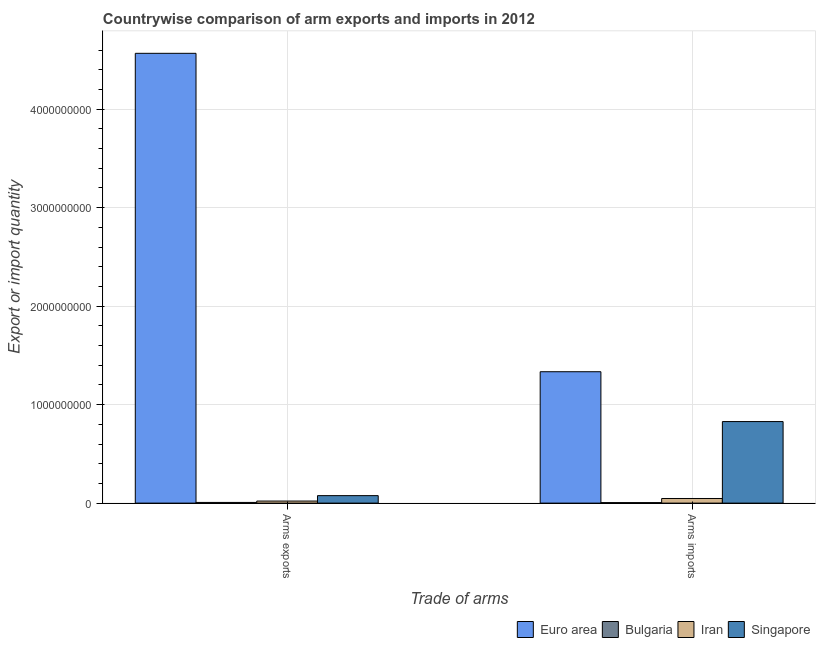How many bars are there on the 2nd tick from the left?
Keep it short and to the point. 4. How many bars are there on the 1st tick from the right?
Keep it short and to the point. 4. What is the label of the 1st group of bars from the left?
Provide a succinct answer. Arms exports. What is the arms exports in Iran?
Keep it short and to the point. 2.10e+07. Across all countries, what is the maximum arms imports?
Your answer should be compact. 1.33e+09. Across all countries, what is the minimum arms imports?
Keep it short and to the point. 5.00e+06. In which country was the arms imports minimum?
Give a very brief answer. Bulgaria. What is the total arms imports in the graph?
Your answer should be compact. 2.21e+09. What is the difference between the arms imports in Singapore and that in Euro area?
Your answer should be very brief. -5.06e+08. What is the difference between the arms exports in Singapore and the arms imports in Bulgaria?
Offer a very short reply. 7.10e+07. What is the average arms imports per country?
Your answer should be very brief. 5.54e+08. What is the difference between the arms imports and arms exports in Bulgaria?
Your answer should be very brief. -2.00e+06. What is the ratio of the arms imports in Bulgaria to that in Singapore?
Provide a short and direct response. 0.01. In how many countries, is the arms exports greater than the average arms exports taken over all countries?
Offer a terse response. 1. What does the 4th bar from the left in Arms exports represents?
Offer a very short reply. Singapore. What does the 1st bar from the right in Arms imports represents?
Offer a terse response. Singapore. How many bars are there?
Ensure brevity in your answer.  8. Are all the bars in the graph horizontal?
Offer a terse response. No. How many countries are there in the graph?
Offer a very short reply. 4. Are the values on the major ticks of Y-axis written in scientific E-notation?
Give a very brief answer. No. Where does the legend appear in the graph?
Provide a short and direct response. Bottom right. How many legend labels are there?
Offer a terse response. 4. How are the legend labels stacked?
Keep it short and to the point. Horizontal. What is the title of the graph?
Your answer should be compact. Countrywise comparison of arm exports and imports in 2012. Does "Rwanda" appear as one of the legend labels in the graph?
Offer a terse response. No. What is the label or title of the X-axis?
Your answer should be very brief. Trade of arms. What is the label or title of the Y-axis?
Ensure brevity in your answer.  Export or import quantity. What is the Export or import quantity of Euro area in Arms exports?
Ensure brevity in your answer.  4.57e+09. What is the Export or import quantity in Bulgaria in Arms exports?
Your answer should be very brief. 7.00e+06. What is the Export or import quantity of Iran in Arms exports?
Provide a succinct answer. 2.10e+07. What is the Export or import quantity of Singapore in Arms exports?
Keep it short and to the point. 7.60e+07. What is the Export or import quantity in Euro area in Arms imports?
Your response must be concise. 1.33e+09. What is the Export or import quantity in Iran in Arms imports?
Your answer should be compact. 4.70e+07. What is the Export or import quantity of Singapore in Arms imports?
Offer a very short reply. 8.28e+08. Across all Trade of arms, what is the maximum Export or import quantity in Euro area?
Offer a terse response. 4.57e+09. Across all Trade of arms, what is the maximum Export or import quantity in Bulgaria?
Your answer should be compact. 7.00e+06. Across all Trade of arms, what is the maximum Export or import quantity in Iran?
Your answer should be very brief. 4.70e+07. Across all Trade of arms, what is the maximum Export or import quantity of Singapore?
Keep it short and to the point. 8.28e+08. Across all Trade of arms, what is the minimum Export or import quantity in Euro area?
Make the answer very short. 1.33e+09. Across all Trade of arms, what is the minimum Export or import quantity in Bulgaria?
Keep it short and to the point. 5.00e+06. Across all Trade of arms, what is the minimum Export or import quantity of Iran?
Make the answer very short. 2.10e+07. Across all Trade of arms, what is the minimum Export or import quantity of Singapore?
Give a very brief answer. 7.60e+07. What is the total Export or import quantity in Euro area in the graph?
Your answer should be very brief. 5.90e+09. What is the total Export or import quantity of Iran in the graph?
Your answer should be compact. 6.80e+07. What is the total Export or import quantity of Singapore in the graph?
Offer a very short reply. 9.04e+08. What is the difference between the Export or import quantity in Euro area in Arms exports and that in Arms imports?
Your answer should be very brief. 3.23e+09. What is the difference between the Export or import quantity in Iran in Arms exports and that in Arms imports?
Offer a terse response. -2.60e+07. What is the difference between the Export or import quantity of Singapore in Arms exports and that in Arms imports?
Offer a very short reply. -7.52e+08. What is the difference between the Export or import quantity of Euro area in Arms exports and the Export or import quantity of Bulgaria in Arms imports?
Your response must be concise. 4.56e+09. What is the difference between the Export or import quantity in Euro area in Arms exports and the Export or import quantity in Iran in Arms imports?
Give a very brief answer. 4.52e+09. What is the difference between the Export or import quantity of Euro area in Arms exports and the Export or import quantity of Singapore in Arms imports?
Make the answer very short. 3.74e+09. What is the difference between the Export or import quantity in Bulgaria in Arms exports and the Export or import quantity in Iran in Arms imports?
Offer a very short reply. -4.00e+07. What is the difference between the Export or import quantity in Bulgaria in Arms exports and the Export or import quantity in Singapore in Arms imports?
Offer a terse response. -8.21e+08. What is the difference between the Export or import quantity of Iran in Arms exports and the Export or import quantity of Singapore in Arms imports?
Offer a terse response. -8.07e+08. What is the average Export or import quantity in Euro area per Trade of arms?
Make the answer very short. 2.95e+09. What is the average Export or import quantity of Iran per Trade of arms?
Make the answer very short. 3.40e+07. What is the average Export or import quantity of Singapore per Trade of arms?
Offer a terse response. 4.52e+08. What is the difference between the Export or import quantity in Euro area and Export or import quantity in Bulgaria in Arms exports?
Your answer should be compact. 4.56e+09. What is the difference between the Export or import quantity in Euro area and Export or import quantity in Iran in Arms exports?
Offer a terse response. 4.55e+09. What is the difference between the Export or import quantity in Euro area and Export or import quantity in Singapore in Arms exports?
Ensure brevity in your answer.  4.49e+09. What is the difference between the Export or import quantity in Bulgaria and Export or import quantity in Iran in Arms exports?
Your answer should be very brief. -1.40e+07. What is the difference between the Export or import quantity of Bulgaria and Export or import quantity of Singapore in Arms exports?
Ensure brevity in your answer.  -6.90e+07. What is the difference between the Export or import quantity of Iran and Export or import quantity of Singapore in Arms exports?
Your answer should be very brief. -5.50e+07. What is the difference between the Export or import quantity of Euro area and Export or import quantity of Bulgaria in Arms imports?
Provide a short and direct response. 1.33e+09. What is the difference between the Export or import quantity of Euro area and Export or import quantity of Iran in Arms imports?
Your response must be concise. 1.29e+09. What is the difference between the Export or import quantity in Euro area and Export or import quantity in Singapore in Arms imports?
Ensure brevity in your answer.  5.06e+08. What is the difference between the Export or import quantity in Bulgaria and Export or import quantity in Iran in Arms imports?
Ensure brevity in your answer.  -4.20e+07. What is the difference between the Export or import quantity in Bulgaria and Export or import quantity in Singapore in Arms imports?
Provide a short and direct response. -8.23e+08. What is the difference between the Export or import quantity of Iran and Export or import quantity of Singapore in Arms imports?
Ensure brevity in your answer.  -7.81e+08. What is the ratio of the Export or import quantity in Euro area in Arms exports to that in Arms imports?
Your answer should be compact. 3.42. What is the ratio of the Export or import quantity of Bulgaria in Arms exports to that in Arms imports?
Your answer should be very brief. 1.4. What is the ratio of the Export or import quantity of Iran in Arms exports to that in Arms imports?
Provide a succinct answer. 0.45. What is the ratio of the Export or import quantity in Singapore in Arms exports to that in Arms imports?
Keep it short and to the point. 0.09. What is the difference between the highest and the second highest Export or import quantity of Euro area?
Offer a terse response. 3.23e+09. What is the difference between the highest and the second highest Export or import quantity of Bulgaria?
Provide a succinct answer. 2.00e+06. What is the difference between the highest and the second highest Export or import quantity of Iran?
Your response must be concise. 2.60e+07. What is the difference between the highest and the second highest Export or import quantity in Singapore?
Provide a succinct answer. 7.52e+08. What is the difference between the highest and the lowest Export or import quantity of Euro area?
Your answer should be compact. 3.23e+09. What is the difference between the highest and the lowest Export or import quantity of Iran?
Your response must be concise. 2.60e+07. What is the difference between the highest and the lowest Export or import quantity of Singapore?
Your answer should be compact. 7.52e+08. 